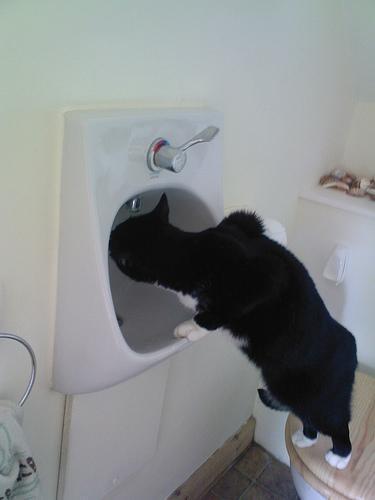How many cats are in the photo?
Give a very brief answer. 1. 